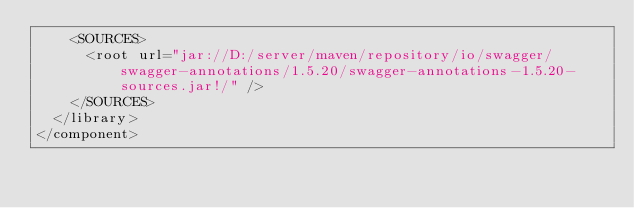Convert code to text. <code><loc_0><loc_0><loc_500><loc_500><_XML_>    <SOURCES>
      <root url="jar://D:/server/maven/repository/io/swagger/swagger-annotations/1.5.20/swagger-annotations-1.5.20-sources.jar!/" />
    </SOURCES>
  </library>
</component></code> 